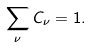<formula> <loc_0><loc_0><loc_500><loc_500>\sum _ { \nu } C _ { \nu } = 1 .</formula> 